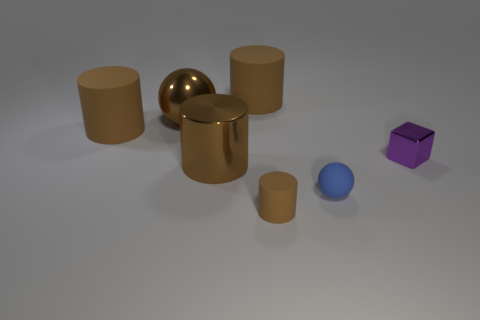Are there more small brown rubber cylinders behind the tiny purple cube than rubber cylinders on the right side of the blue sphere?
Offer a very short reply. No. There is a ball on the left side of the rubber ball; is it the same size as the metal cylinder left of the small matte cylinder?
Give a very brief answer. Yes. What is the shape of the tiny blue thing?
Provide a succinct answer. Sphere. There is a metal cylinder that is the same color as the large metal sphere; what size is it?
Provide a succinct answer. Large. There is a ball that is the same material as the small brown thing; what color is it?
Your answer should be compact. Blue. Is the tiny purple block made of the same material as the ball that is to the right of the tiny cylinder?
Ensure brevity in your answer.  No. The small metallic object is what color?
Your answer should be compact. Purple. What size is the cylinder that is made of the same material as the brown sphere?
Keep it short and to the point. Large. There is a matte object that is to the left of the brown metallic thing behind the small purple metal thing; what number of big matte cylinders are right of it?
Your answer should be very brief. 1. Does the matte sphere have the same color as the small matte thing to the left of the small matte ball?
Make the answer very short. No. 